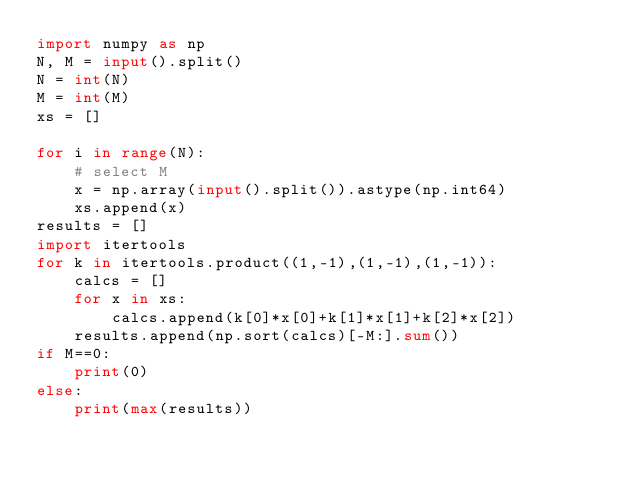Convert code to text. <code><loc_0><loc_0><loc_500><loc_500><_Python_>import numpy as np 
N, M = input().split()
N = int(N)
M = int(M)
xs = []

for i in range(N):
    # select M
    x = np.array(input().split()).astype(np.int64)
    xs.append(x)
results = []
import itertools
for k in itertools.product((1,-1),(1,-1),(1,-1)):
    calcs = []
    for x in xs:
        calcs.append(k[0]*x[0]+k[1]*x[1]+k[2]*x[2])
    results.append(np.sort(calcs)[-M:].sum())
if M==0:
    print(0)
else:
    print(max(results))</code> 